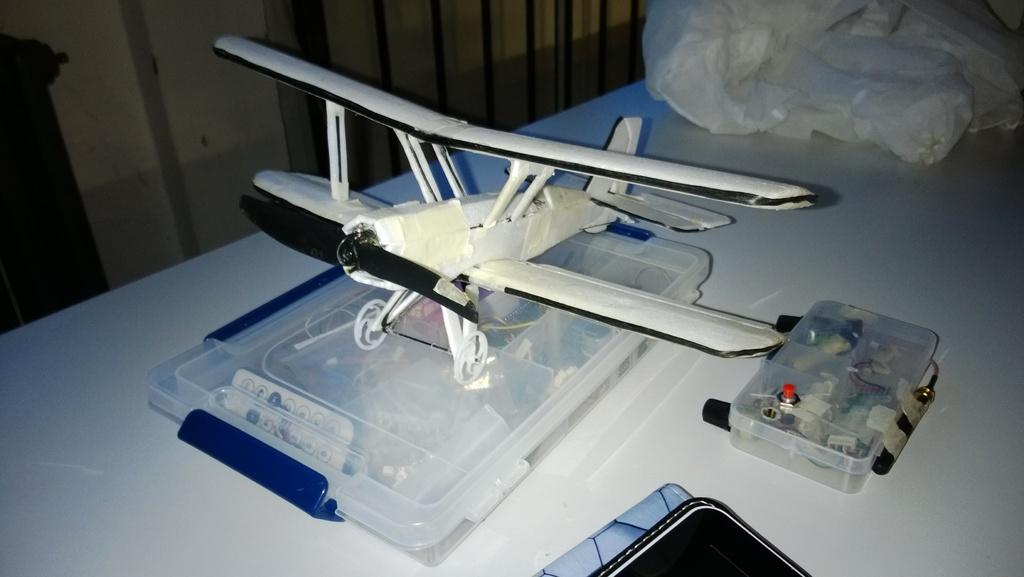What is the main subject of the image? The main subject of the image is an airplane on a box. What other object can be seen in the image? There is a remote control in the image. Where is the cover located in the image? The cover is in the top right of the image. What time of day is depicted in the image? The time of day cannot be determined from the image, as there are no indications of morning or any other time. 